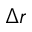<formula> <loc_0><loc_0><loc_500><loc_500>\Delta r</formula> 